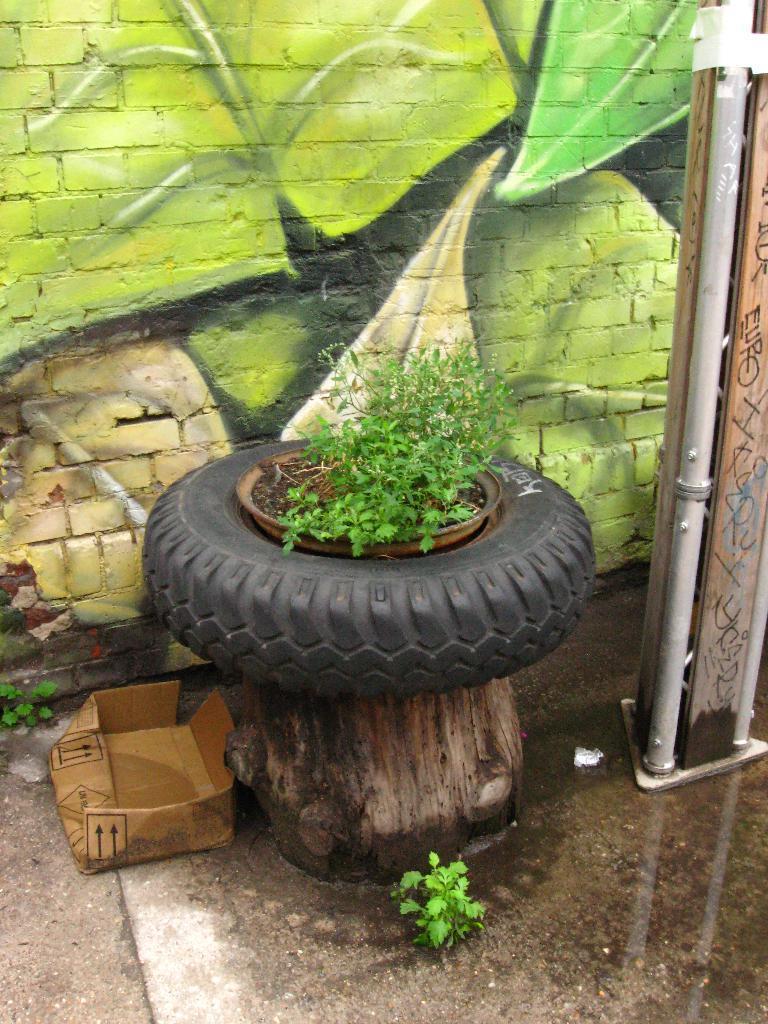Please provide a concise description of this image. In this picture we can see a tire, house plant, box, pipe and in the background we can see a wall with painting. 